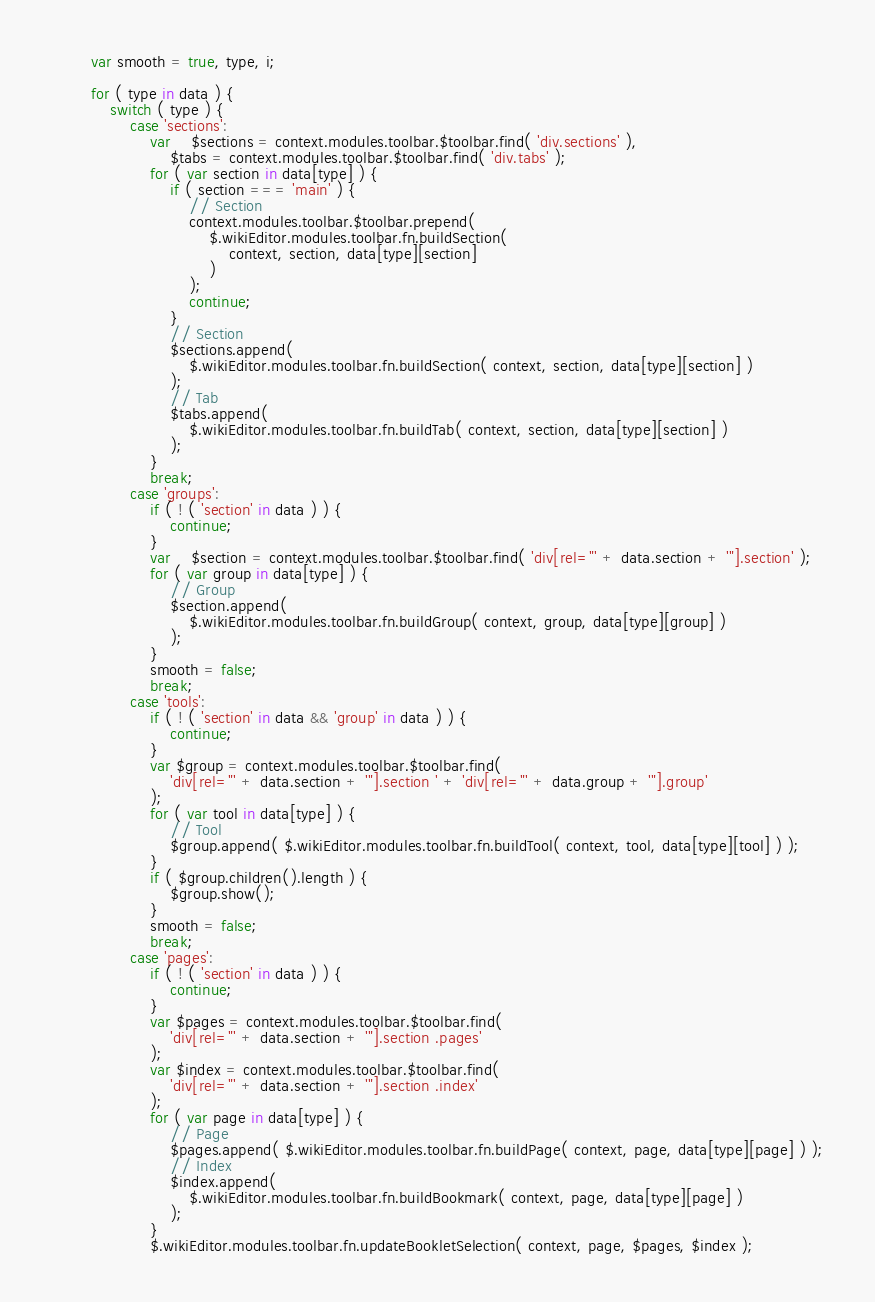<code> <loc_0><loc_0><loc_500><loc_500><_JavaScript_>
		var smooth = true, type, i;

		for ( type in data ) {
			switch ( type ) {
				case 'sections':
					var	$sections = context.modules.toolbar.$toolbar.find( 'div.sections' ),
						$tabs = context.modules.toolbar.$toolbar.find( 'div.tabs' );
					for ( var section in data[type] ) {
						if ( section === 'main' ) {
							// Section
							context.modules.toolbar.$toolbar.prepend(
								$.wikiEditor.modules.toolbar.fn.buildSection(
									context, section, data[type][section]
								)
							);
							continue;
						}
						// Section
						$sections.append(
							$.wikiEditor.modules.toolbar.fn.buildSection( context, section, data[type][section] )
						);
						// Tab
						$tabs.append(
							$.wikiEditor.modules.toolbar.fn.buildTab( context, section, data[type][section] )
						);
					}
					break;
				case 'groups':
					if ( ! ( 'section' in data ) ) {
						continue;
					}
					var	$section = context.modules.toolbar.$toolbar.find( 'div[rel="' + data.section + '"].section' );
					for ( var group in data[type] ) {
						// Group
						$section.append(
							$.wikiEditor.modules.toolbar.fn.buildGroup( context, group, data[type][group] )
						);
					}
					smooth = false;
					break;
				case 'tools':
					if ( ! ( 'section' in data && 'group' in data ) ) {
						continue;
					}
					var $group = context.modules.toolbar.$toolbar.find(
						'div[rel="' + data.section + '"].section ' + 'div[rel="' + data.group + '"].group'
					);
					for ( var tool in data[type] ) {
						// Tool
						$group.append( $.wikiEditor.modules.toolbar.fn.buildTool( context, tool, data[type][tool] ) );
					}
					if ( $group.children().length ) {
						$group.show();
					}
					smooth = false;
					break;
				case 'pages':
					if ( ! ( 'section' in data ) ) {
						continue;
					}
					var $pages = context.modules.toolbar.$toolbar.find(
						'div[rel="' + data.section + '"].section .pages'
					);
					var $index = context.modules.toolbar.$toolbar.find(
						'div[rel="' + data.section + '"].section .index'
					);
					for ( var page in data[type] ) {
						// Page
						$pages.append( $.wikiEditor.modules.toolbar.fn.buildPage( context, page, data[type][page] ) );
						// Index
						$index.append(
							$.wikiEditor.modules.toolbar.fn.buildBookmark( context, page, data[type][page] )
						);
					}
					$.wikiEditor.modules.toolbar.fn.updateBookletSelection( context, page, $pages, $index );</code> 